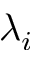<formula> <loc_0><loc_0><loc_500><loc_500>\lambda _ { i }</formula> 